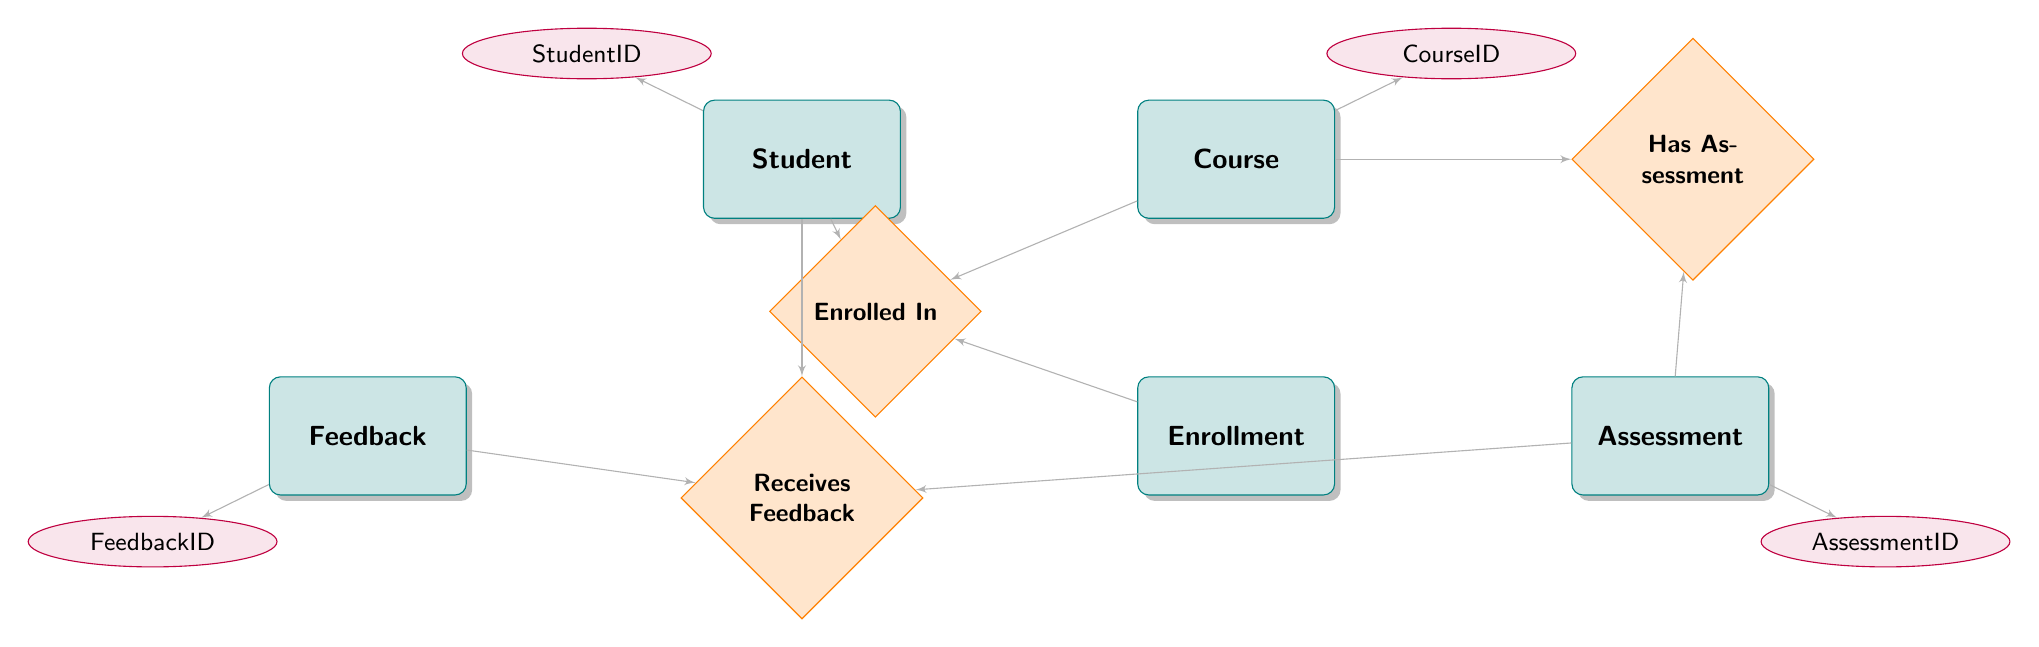What's the primary key of the Student entity? The primary key for the Student entity is StudentID, which is indicated at the top of the Student node within the diagram.
Answer: StudentID How many attributes are associated with the Course entity? The Course entity has four attributes: CourseID, CourseName, Description, and Credits. These are listed under the Course node in the diagram.
Answer: Four Which entity is connected to the Feedback entity via the relationship "Receives Feedback"? The Student entity is connected to the Feedback entity through the "Receives Feedback" relationship, as indicated by the connecting lines in the diagram leading from Student to Feedback.
Answer: Student What relationship connects the Student and Course entities? The relationship that connects the Student and Course entities is called "Enrolled In," as shown in the diagram which includes both entities and the relationship diamond in between.
Answer: Enrolled In What is the maximum score for the Assessment entity? There is no specific maximum score mentioned in the diagram for the Assessment entity, as it is indicated but not defined in this instance.
Answer: Not specified How does the Assessment entity relate to the Course entity? The Assessment entity is connected to the Course entity through the "Has Assessment" relationship, indicating that assessments are associated with specific courses.
Answer: Has Assessment Can a student receive feedback for multiple assessments? Yes, a student can receive feedback for multiple assessments, as shown by the connecting "Receives Feedback" relationship which allows multiple feedback entries linked to different assessments.
Answer: Yes Which entities are involved when a student enrolls in a course? The entities involved when a student enrolls in a course are Student, Enrollment, and Course, as indicated by the "Enrolled In" relationship which connects these three nodes.
Answer: Student, Enrollment, Course What does the Feedback entity include regarding details? The Feedback entity includes attributes such as FeedbackID, StudentID, AssessmentID, Comments, and FeedbackDate, which are detailed in the attributes section of the Feedback node.
Answer: FeedbackID, StudentID, AssessmentID, Comments, FeedbackDate 